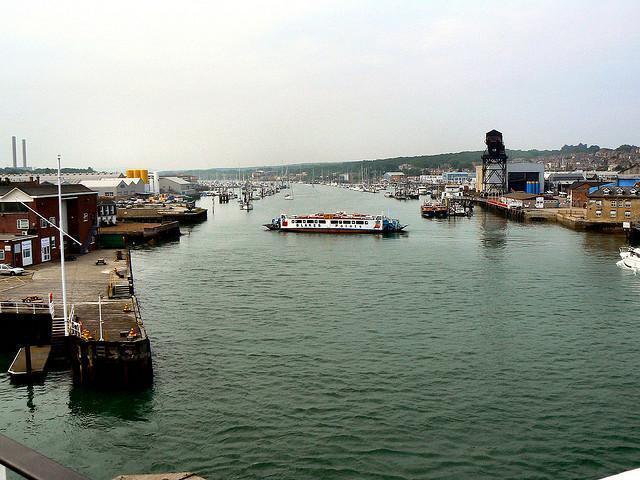What color are the end bridges for the boat suspended in the middle of the river?
Indicate the correct choice and explain in the format: 'Answer: answer
Rationale: rationale.'
Options: Blue, white, red, green. Answer: blue.
Rationale: The color is blue. 